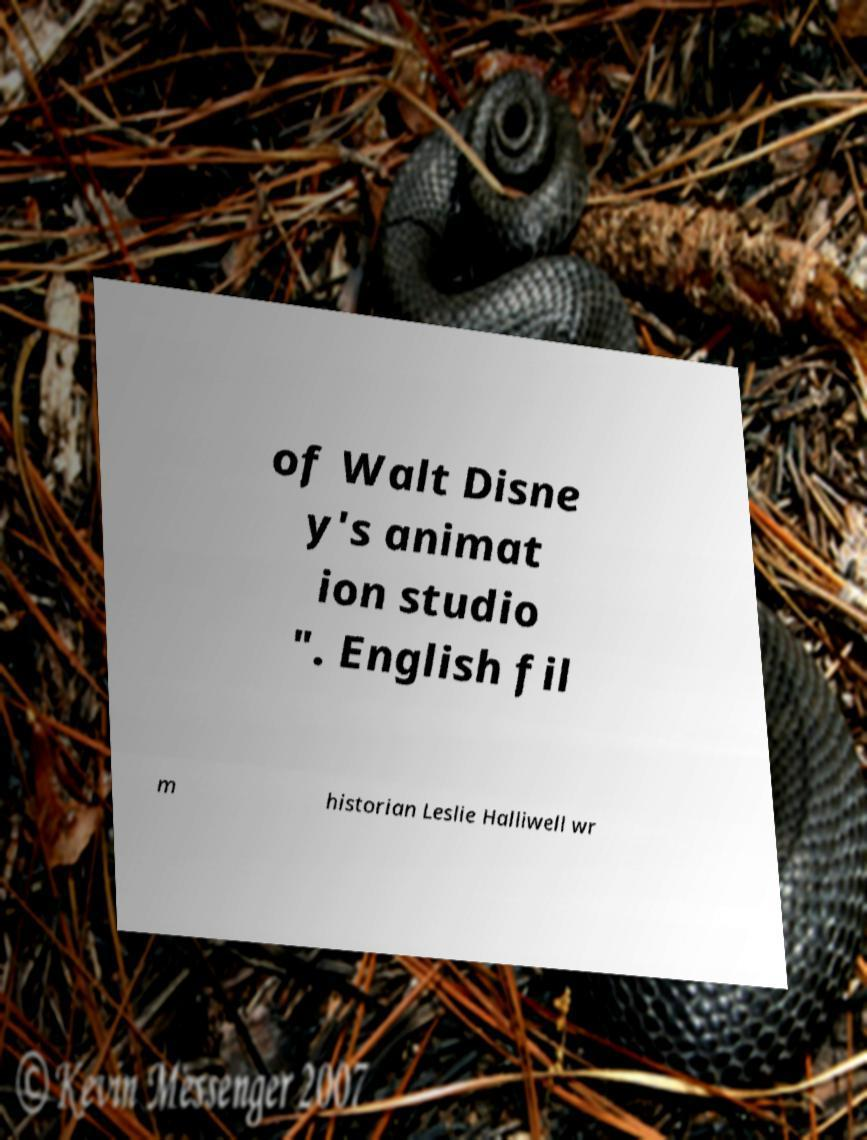Can you accurately transcribe the text from the provided image for me? of Walt Disne y's animat ion studio ". English fil m historian Leslie Halliwell wr 